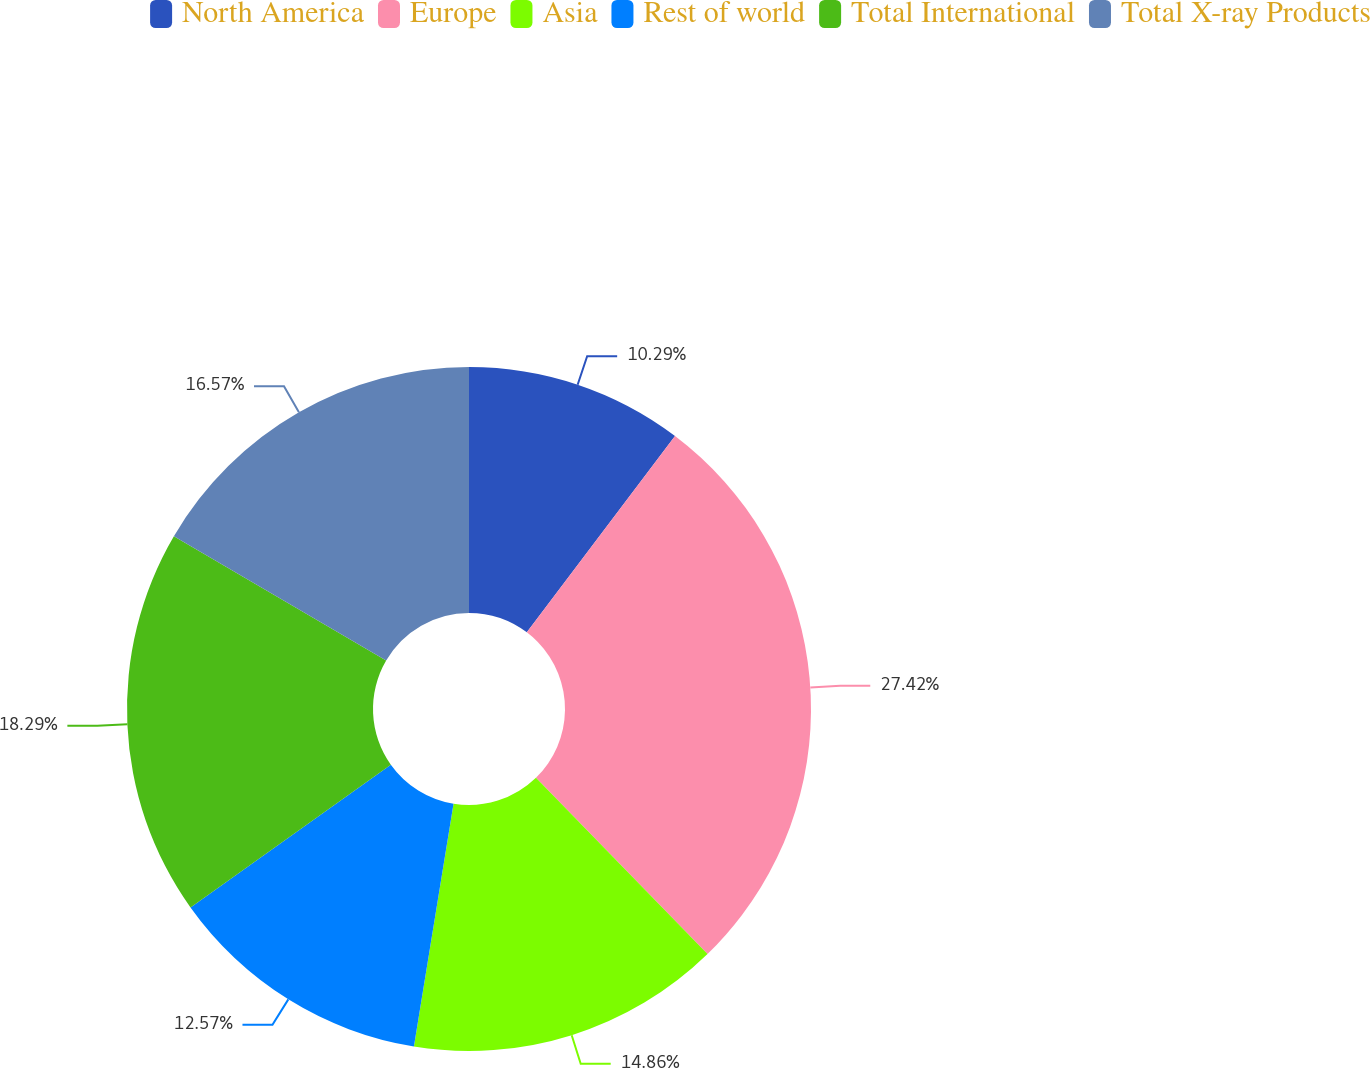Convert chart to OTSL. <chart><loc_0><loc_0><loc_500><loc_500><pie_chart><fcel>North America<fcel>Europe<fcel>Asia<fcel>Rest of world<fcel>Total International<fcel>Total X-ray Products<nl><fcel>10.29%<fcel>27.43%<fcel>14.86%<fcel>12.57%<fcel>18.29%<fcel>16.57%<nl></chart> 